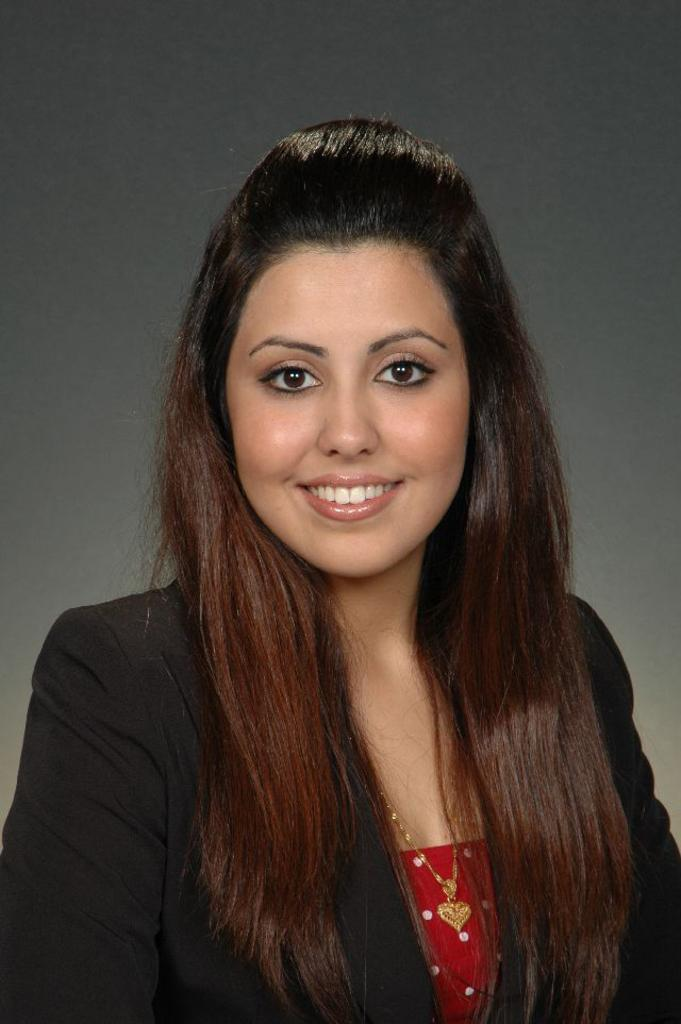Who is the main subject in the image? There is a woman in the image. What can be observed about the background of the image? The background of the image is dark. How much money is the woman holding in the image? There is no indication of money in the image, so it cannot be determined. 